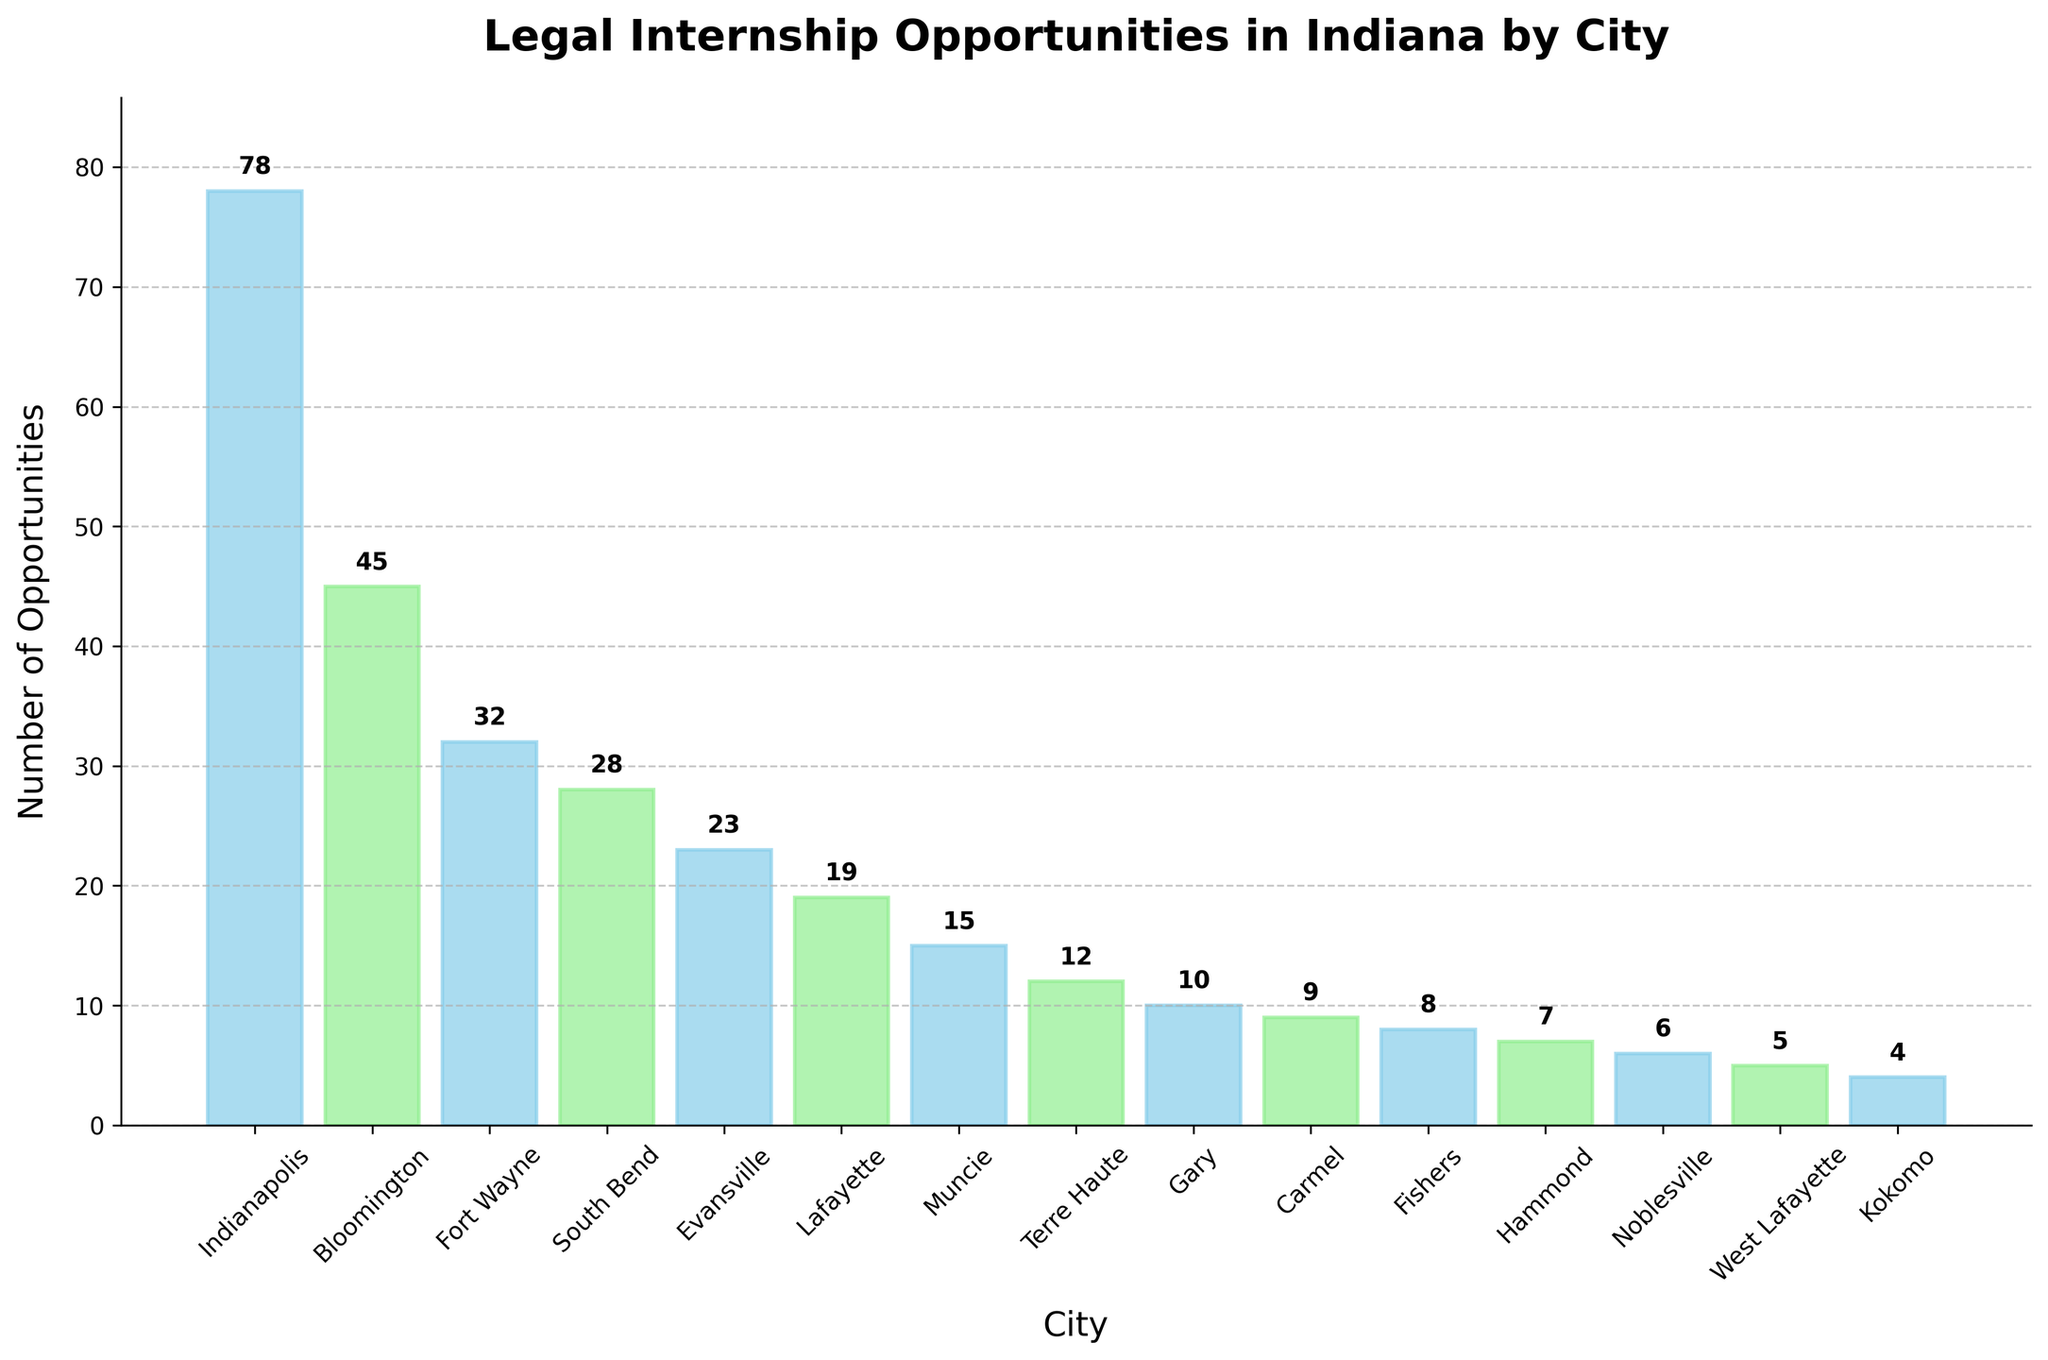What's the city with the highest number of legal internship opportunities? The bar chart shows the number of legal internship opportunities by city in Indiana. By visually scanning the chart, we can see that Indianapolis has the tallest bar, indicating it has the highest number of opportunities.
Answer: Indianapolis Which two cities have a combined total of 53 legal internship opportunities? To find this, scan the heights of the bars and corresponding values. Bloomington has 45 opportunities, and Gary has 10, providing a combined total of 55. However, Lafayette (19) and Fort Wayne (32) give us the sum of 51, which isn't correct either. Thus, Bloomington (45) and Terre Haute (12) add up to 57. So, there isn't a combination of two cities exactly adding up to 53 but the correct cities adding closest in value are Bloomington (45) and Terre Haute (12).
Answer: None exactly, close values are Bloomington and Terre Haute Which city has 5 legal internship opportunities? Visually inspect each bar and label, observing that the bar representing West Lafayette shows 5 opportunities.
Answer: West Lafayette How many more internship opportunities does South Bend have compared to Lafayette? By reading the values associated with each bar, South Bend has 28 opportunities and Lafayette has 19. Therefore, the difference is 28 - 19.
Answer: 9 What is the combined number of internship opportunities in Fishers, Hammond, and Noblesville? Visually assess the chart to find the respective counts for Fishers (8), Hammond (7), and Noblesville (6). Summing these values provides the total: 8 + 7 + 6 = 21.
Answer: 21 Which city has the least number of legal internship opportunities and how many? The shortest bar will indicate the city with the smallest number of opportunities. By inspecting, Kokomo has the fewest with just 4.
Answer: Kokomo with 4 What feature distinguishes bars with even indices from bars with odd indices in the chart? By observing the color patterns, bars with even indices are colored in sky blue while bars with odd indices are colored in light green.
Answer: Even-index bars are sky blue, odd-index bars are light green How many cities offer more than 20 legal internship opportunities? Identify all bars extending above the 20-unit mark from the y-axis. From the chart, cities with such bars are Indianapolis (78), Bloomington (45), Fort Wayne (32), South Bend (28), and Evansville (23). In total, 5 cities offer more than 20 opportunities.
Answer: 5 What average number of internship opportunities is available in the three cities with the highest opportunities? The three cities with the highest values are Indianapolis (78), Bloomington (45), and Fort Wayne (32). Calculate the sum (78 + 45 + 32) and divide it by 3. This results in an average of (155 / 3) ≈ 51.67 opportunities.
Answer: 51.67 